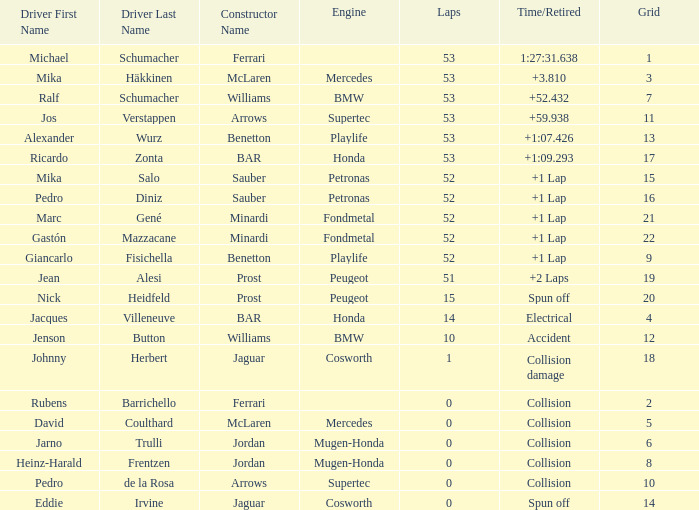For a grid number having under 52 laps and a collision-based time/retired status, which one belongs to the arrows-supertec constructor? 1.0. 